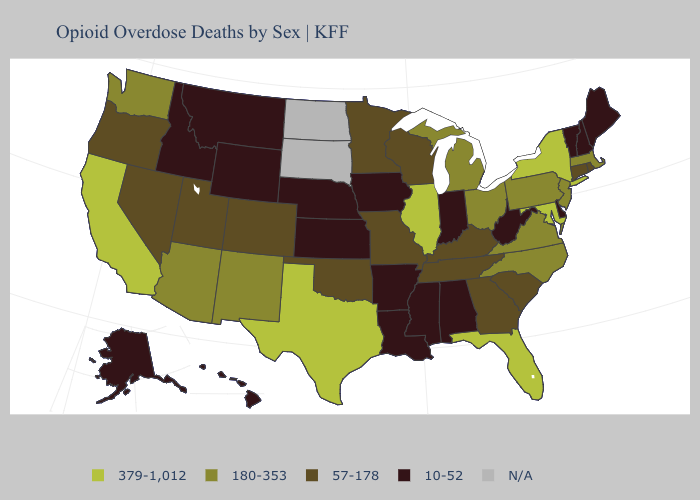Name the states that have a value in the range N/A?
Write a very short answer. North Dakota, South Dakota. Name the states that have a value in the range 57-178?
Quick response, please. Colorado, Connecticut, Georgia, Kentucky, Minnesota, Missouri, Nevada, Oklahoma, Oregon, Rhode Island, South Carolina, Tennessee, Utah, Wisconsin. What is the highest value in the West ?
Concise answer only. 379-1,012. What is the lowest value in the West?
Write a very short answer. 10-52. What is the highest value in states that border Wyoming?
Keep it brief. 57-178. Among the states that border Missouri , which have the lowest value?
Write a very short answer. Arkansas, Iowa, Kansas, Nebraska. What is the value of Maryland?
Write a very short answer. 379-1,012. Name the states that have a value in the range N/A?
Quick response, please. North Dakota, South Dakota. How many symbols are there in the legend?
Give a very brief answer. 5. What is the lowest value in the West?
Be succinct. 10-52. Does Florida have the highest value in the USA?
Give a very brief answer. Yes. What is the value of North Dakota?
Answer briefly. N/A. What is the value of Texas?
Answer briefly. 379-1,012. Which states have the lowest value in the South?
Be succinct. Alabama, Arkansas, Delaware, Louisiana, Mississippi, West Virginia. Name the states that have a value in the range 379-1,012?
Quick response, please. California, Florida, Illinois, Maryland, New York, Texas. 